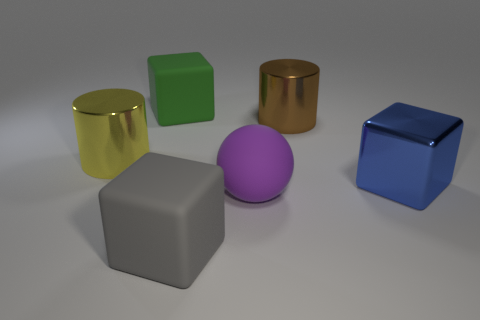Subtract 1 cubes. How many cubes are left? 2 Subtract all rubber cubes. How many cubes are left? 1 Add 4 small cyan objects. How many objects exist? 10 Subtract all balls. How many objects are left? 5 Add 6 big yellow balls. How many big yellow balls exist? 6 Subtract 1 green cubes. How many objects are left? 5 Subtract all large yellow metal things. Subtract all big gray matte things. How many objects are left? 4 Add 2 big metal cubes. How many big metal cubes are left? 3 